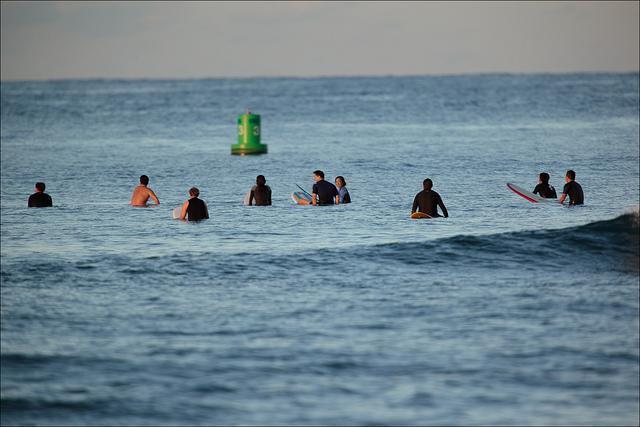Where are the people hanging out?
Choose the correct response, then elucidate: 'Answer: answer
Rationale: rationale.'
Options: Bathroom, water, sand, restaurant. Answer: water.
Rationale: The people are by water. 